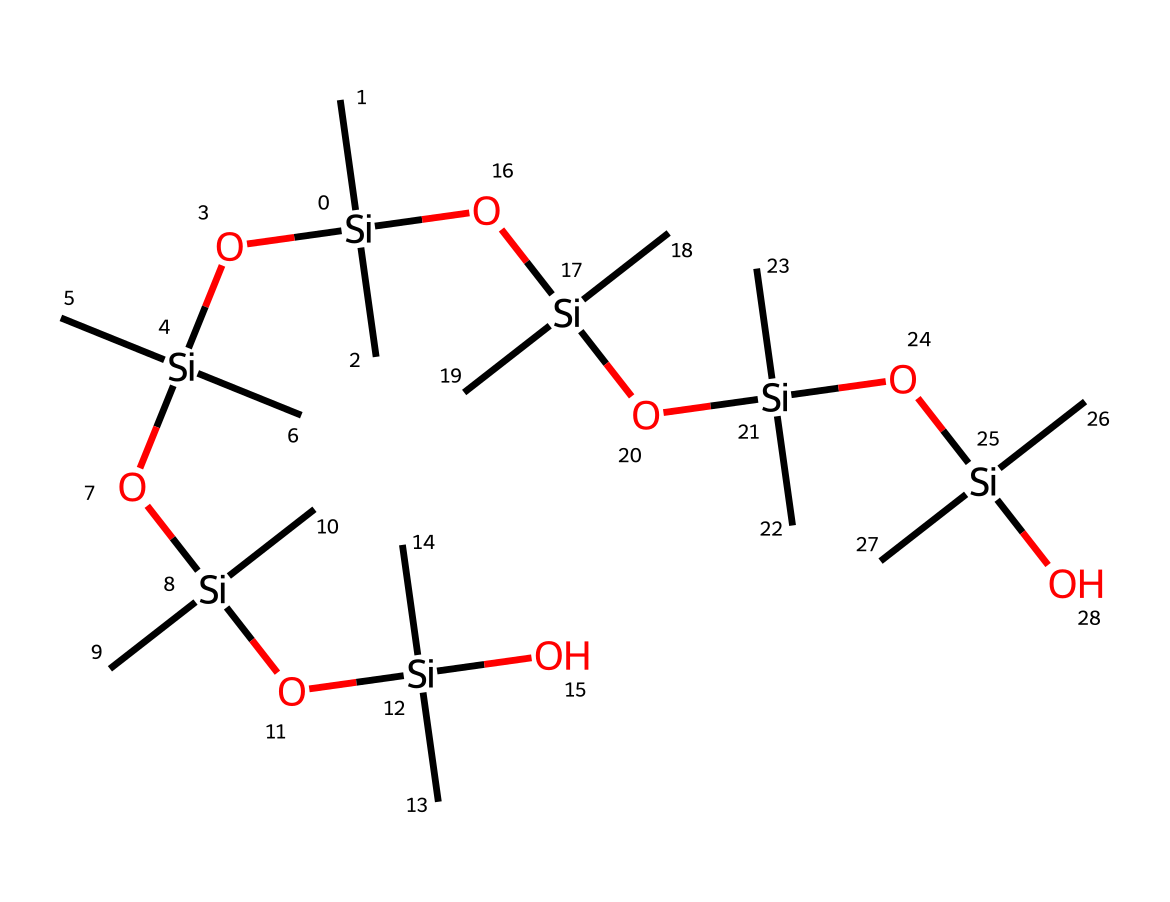what is the main element in this chemical structure? The chemical structure prominently features silicon (Si) as the central atom connecting various groups, which is highlighted by its presence and the surrounding carbon and oxygen atoms.
Answer: silicon how many silicon atoms are present in the structure? By examining the SMILES representation, there are five silicon atoms represented; each is indicated by the letter “Si” in the structure.
Answer: five what type of functional groups are present in this compound? The compound includes hydroxyl groups (–OH) as denoted by the oxygen atoms bonded to silicon atoms, which suggests the presence of silanol groups.
Answer: silanol groups how does this chemical contribute to water-repellent properties? The presence of hydrophobic methyl groups (–Si(C)(C)–) linked to silicon domains creates a surface that minimizes wetting, thus enhancing water repellency.
Answer: hydrophobic how does the structure of this silicone contribute to elasticity in athletic gear? The extensive siloxane (Si-O) linkages in the polymer backbone allow for flexibility and elasticity, which are critical in athletic wear for movement and comfort.
Answer: flexibility is this chemical a solid, liquid, or gas at room temperature? The structure of silicone polymers like this one typically exists as a pliable solid at room temperature due to their long chain polymer structure and cross-linking.
Answer: solid what makes the compound a non-electrolyte? Since the chemical structure does not contain ionic bonds or readily dissociable ions in solution, it classifies as a non-electrolyte, retaining its molecular integrity.
Answer: non-electrolyte 